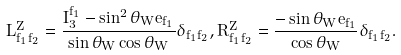<formula> <loc_0><loc_0><loc_500><loc_500>L ^ { Z } _ { f _ { 1 } f _ { 2 } } = \frac { I _ { 3 } ^ { f _ { 1 } } - \sin ^ { 2 } \theta _ { W } e _ { f _ { 1 } } } { \sin \theta _ { W } \cos \theta _ { W } } \delta _ { f _ { 1 } f _ { 2 } } , R ^ { Z } _ { f _ { 1 } f _ { 2 } } = \frac { - \sin \theta _ { W } e _ { f _ { 1 } } } { \cos \theta _ { W } } \delta _ { f _ { 1 } f _ { 2 } } .</formula> 